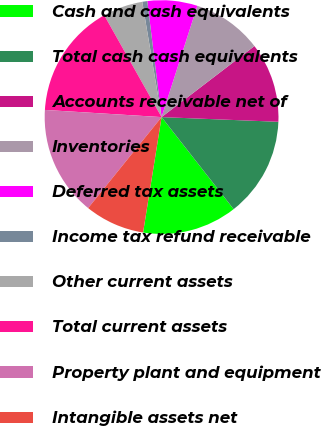Convert chart. <chart><loc_0><loc_0><loc_500><loc_500><pie_chart><fcel>Cash and cash equivalents<fcel>Total cash cash equivalents<fcel>Accounts receivable net of<fcel>Inventories<fcel>Deferred tax assets<fcel>Income tax refund receivable<fcel>Other current assets<fcel>Total current assets<fcel>Property plant and equipment<fcel>Intangible assets net<nl><fcel>13.1%<fcel>13.79%<fcel>11.03%<fcel>9.66%<fcel>6.9%<fcel>0.69%<fcel>5.52%<fcel>15.86%<fcel>15.17%<fcel>8.28%<nl></chart> 